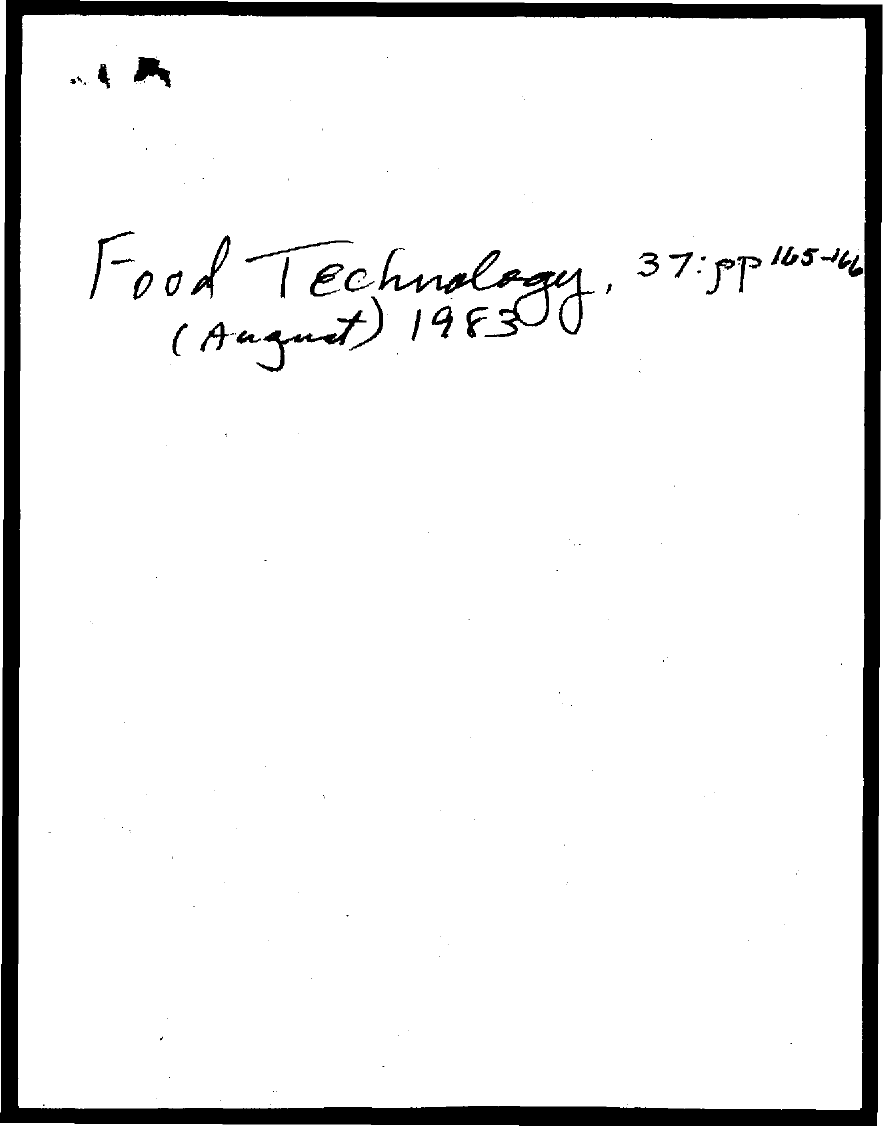Which year is mentioned in the document?
Provide a short and direct response. 1983. Which month is mentioned in the document?
Your response must be concise. (August). 